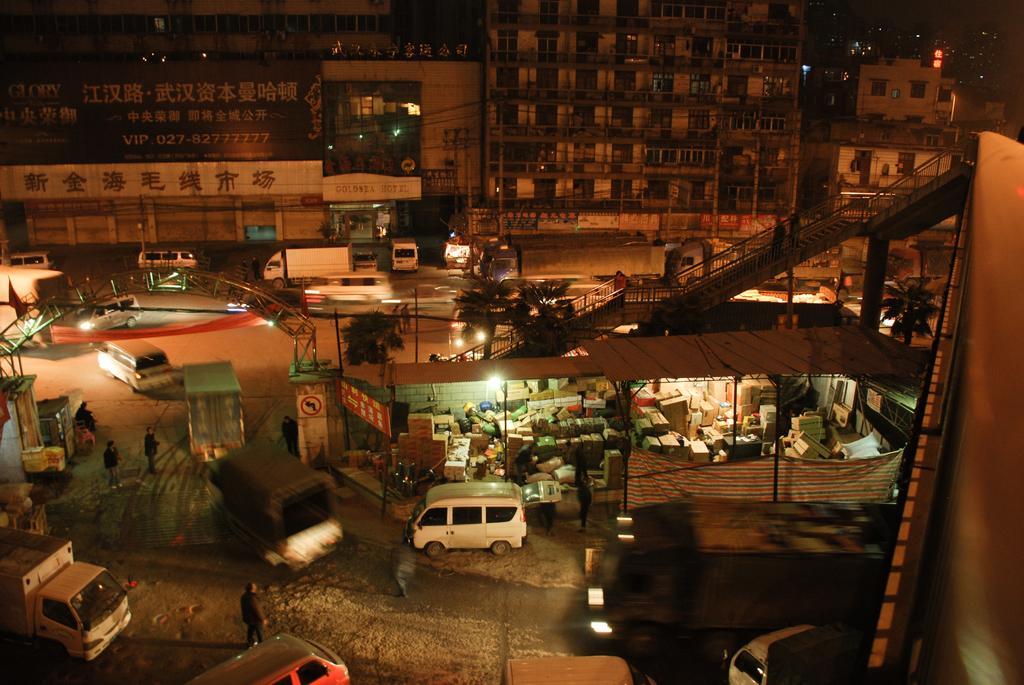Please provide a concise description of this image. In this image we can see vehicles and persons are standing on the road, carton boxes, open sheds, poles, lights, railings, steps, trees, buildings, wires, name boards on the walls, glass doors, windows and other objects. 